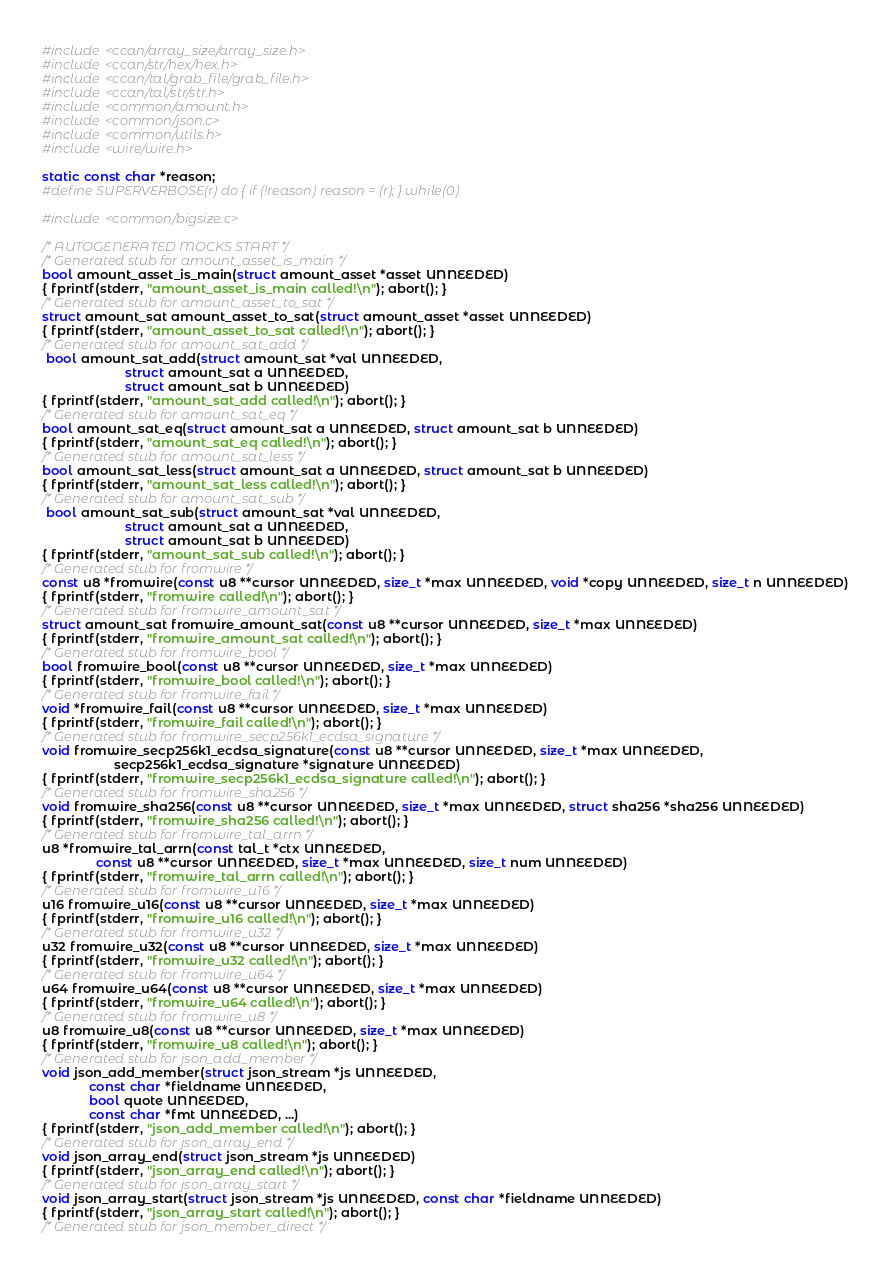<code> <loc_0><loc_0><loc_500><loc_500><_C_>#include <ccan/array_size/array_size.h>
#include <ccan/str/hex/hex.h>
#include <ccan/tal/grab_file/grab_file.h>
#include <ccan/tal/str/str.h>
#include <common/amount.h>
#include <common/json.c>
#include <common/utils.h>
#include <wire/wire.h>

static const char *reason;
#define SUPERVERBOSE(r) do { if (!reason) reason = (r); } while(0)

#include <common/bigsize.c>

/* AUTOGENERATED MOCKS START */
/* Generated stub for amount_asset_is_main */
bool amount_asset_is_main(struct amount_asset *asset UNNEEDED)
{ fprintf(stderr, "amount_asset_is_main called!\n"); abort(); }
/* Generated stub for amount_asset_to_sat */
struct amount_sat amount_asset_to_sat(struct amount_asset *asset UNNEEDED)
{ fprintf(stderr, "amount_asset_to_sat called!\n"); abort(); }
/* Generated stub for amount_sat_add */
 bool amount_sat_add(struct amount_sat *val UNNEEDED,
				       struct amount_sat a UNNEEDED,
				       struct amount_sat b UNNEEDED)
{ fprintf(stderr, "amount_sat_add called!\n"); abort(); }
/* Generated stub for amount_sat_eq */
bool amount_sat_eq(struct amount_sat a UNNEEDED, struct amount_sat b UNNEEDED)
{ fprintf(stderr, "amount_sat_eq called!\n"); abort(); }
/* Generated stub for amount_sat_less */
bool amount_sat_less(struct amount_sat a UNNEEDED, struct amount_sat b UNNEEDED)
{ fprintf(stderr, "amount_sat_less called!\n"); abort(); }
/* Generated stub for amount_sat_sub */
 bool amount_sat_sub(struct amount_sat *val UNNEEDED,
				       struct amount_sat a UNNEEDED,
				       struct amount_sat b UNNEEDED)
{ fprintf(stderr, "amount_sat_sub called!\n"); abort(); }
/* Generated stub for fromwire */
const u8 *fromwire(const u8 **cursor UNNEEDED, size_t *max UNNEEDED, void *copy UNNEEDED, size_t n UNNEEDED)
{ fprintf(stderr, "fromwire called!\n"); abort(); }
/* Generated stub for fromwire_amount_sat */
struct amount_sat fromwire_amount_sat(const u8 **cursor UNNEEDED, size_t *max UNNEEDED)
{ fprintf(stderr, "fromwire_amount_sat called!\n"); abort(); }
/* Generated stub for fromwire_bool */
bool fromwire_bool(const u8 **cursor UNNEEDED, size_t *max UNNEEDED)
{ fprintf(stderr, "fromwire_bool called!\n"); abort(); }
/* Generated stub for fromwire_fail */
void *fromwire_fail(const u8 **cursor UNNEEDED, size_t *max UNNEEDED)
{ fprintf(stderr, "fromwire_fail called!\n"); abort(); }
/* Generated stub for fromwire_secp256k1_ecdsa_signature */
void fromwire_secp256k1_ecdsa_signature(const u8 **cursor UNNEEDED, size_t *max UNNEEDED,
					secp256k1_ecdsa_signature *signature UNNEEDED)
{ fprintf(stderr, "fromwire_secp256k1_ecdsa_signature called!\n"); abort(); }
/* Generated stub for fromwire_sha256 */
void fromwire_sha256(const u8 **cursor UNNEEDED, size_t *max UNNEEDED, struct sha256 *sha256 UNNEEDED)
{ fprintf(stderr, "fromwire_sha256 called!\n"); abort(); }
/* Generated stub for fromwire_tal_arrn */
u8 *fromwire_tal_arrn(const tal_t *ctx UNNEEDED,
		       const u8 **cursor UNNEEDED, size_t *max UNNEEDED, size_t num UNNEEDED)
{ fprintf(stderr, "fromwire_tal_arrn called!\n"); abort(); }
/* Generated stub for fromwire_u16 */
u16 fromwire_u16(const u8 **cursor UNNEEDED, size_t *max UNNEEDED)
{ fprintf(stderr, "fromwire_u16 called!\n"); abort(); }
/* Generated stub for fromwire_u32 */
u32 fromwire_u32(const u8 **cursor UNNEEDED, size_t *max UNNEEDED)
{ fprintf(stderr, "fromwire_u32 called!\n"); abort(); }
/* Generated stub for fromwire_u64 */
u64 fromwire_u64(const u8 **cursor UNNEEDED, size_t *max UNNEEDED)
{ fprintf(stderr, "fromwire_u64 called!\n"); abort(); }
/* Generated stub for fromwire_u8 */
u8 fromwire_u8(const u8 **cursor UNNEEDED, size_t *max UNNEEDED)
{ fprintf(stderr, "fromwire_u8 called!\n"); abort(); }
/* Generated stub for json_add_member */
void json_add_member(struct json_stream *js UNNEEDED,
		     const char *fieldname UNNEEDED,
		     bool quote UNNEEDED,
		     const char *fmt UNNEEDED, ...)
{ fprintf(stderr, "json_add_member called!\n"); abort(); }
/* Generated stub for json_array_end */
void json_array_end(struct json_stream *js UNNEEDED)
{ fprintf(stderr, "json_array_end called!\n"); abort(); }
/* Generated stub for json_array_start */
void json_array_start(struct json_stream *js UNNEEDED, const char *fieldname UNNEEDED)
{ fprintf(stderr, "json_array_start called!\n"); abort(); }
/* Generated stub for json_member_direct */</code> 